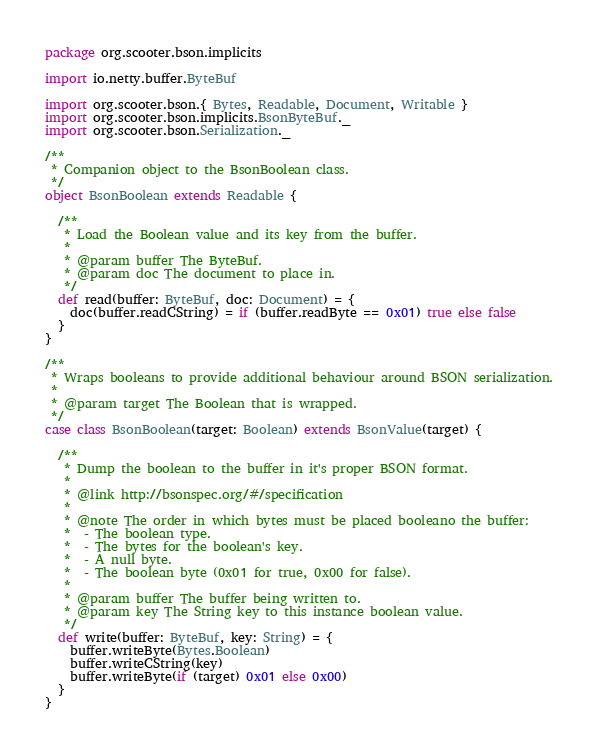<code> <loc_0><loc_0><loc_500><loc_500><_Scala_>package org.scooter.bson.implicits

import io.netty.buffer.ByteBuf

import org.scooter.bson.{ Bytes, Readable, Document, Writable }
import org.scooter.bson.implicits.BsonByteBuf._
import org.scooter.bson.Serialization._

/**
 * Companion object to the BsonBoolean class.
 */
object BsonBoolean extends Readable {

  /**
   * Load the Boolean value and its key from the buffer.
   *
   * @param buffer The ByteBuf.
   * @param doc The document to place in.
   */
  def read(buffer: ByteBuf, doc: Document) = {
    doc(buffer.readCString) = if (buffer.readByte == 0x01) true else false
  }
}

/**
 * Wraps booleans to provide additional behaviour around BSON serialization.
 *
 * @param target The Boolean that is wrapped.
 */
case class BsonBoolean(target: Boolean) extends BsonValue(target) {

  /**
   * Dump the boolean to the buffer in it's proper BSON format.
   *
   * @link http://bsonspec.org/#/specification
   *
   * @note The order in which bytes must be placed booleano the buffer:
   *  - The boolean type.
   *  - The bytes for the boolean's key.
   *  - A null byte.
   *  - The boolean byte (0x01 for true, 0x00 for false).
   *
   * @param buffer The buffer being written to.
   * @param key The String key to this instance boolean value.
   */
  def write(buffer: ByteBuf, key: String) = {
    buffer.writeByte(Bytes.Boolean)
    buffer.writeCString(key)
    buffer.writeByte(if (target) 0x01 else 0x00)
  }
}
</code> 